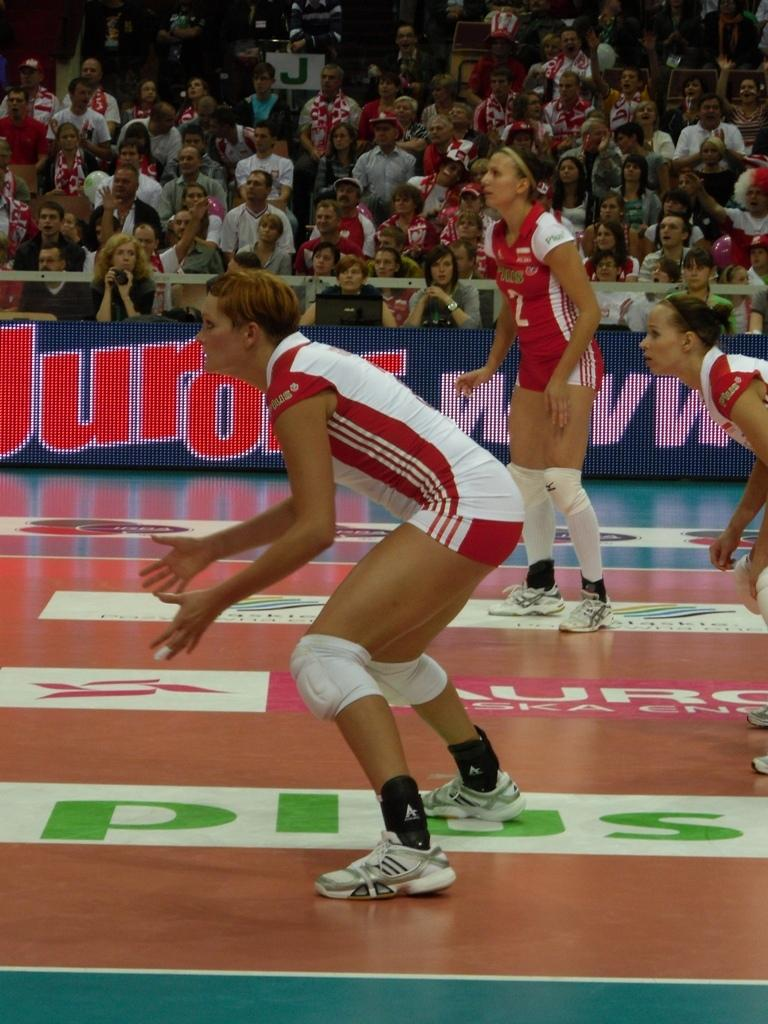What are the women in the image doing? The women are playing a game in the image. Who is watching the women play the game? There is an audience in the image, and they are seated and watching the game. What type of prison can be seen in the background of the image? There is no prison present in the image; it features women playing a game and an audience watching them. How many clocks are visible in the image? There are no clocks visible in the image. 